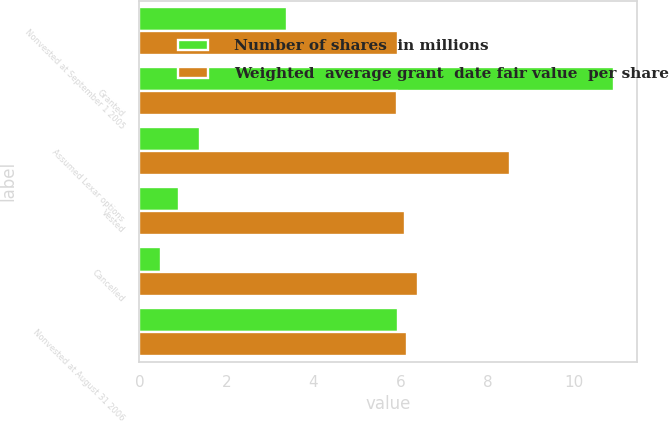Convert chart. <chart><loc_0><loc_0><loc_500><loc_500><stacked_bar_chart><ecel><fcel>Nonvested at September 1 2005<fcel>Granted<fcel>Assumed Lexar options<fcel>Vested<fcel>Cancelled<fcel>Nonvested at August 31 2006<nl><fcel>Number of shares  in millions<fcel>3.4<fcel>10.9<fcel>1.4<fcel>0.9<fcel>0.5<fcel>5.94<nl><fcel>Weighted  average grant  date fair value  per share<fcel>5.94<fcel>5.92<fcel>8.53<fcel>6.11<fcel>6.41<fcel>6.15<nl></chart> 